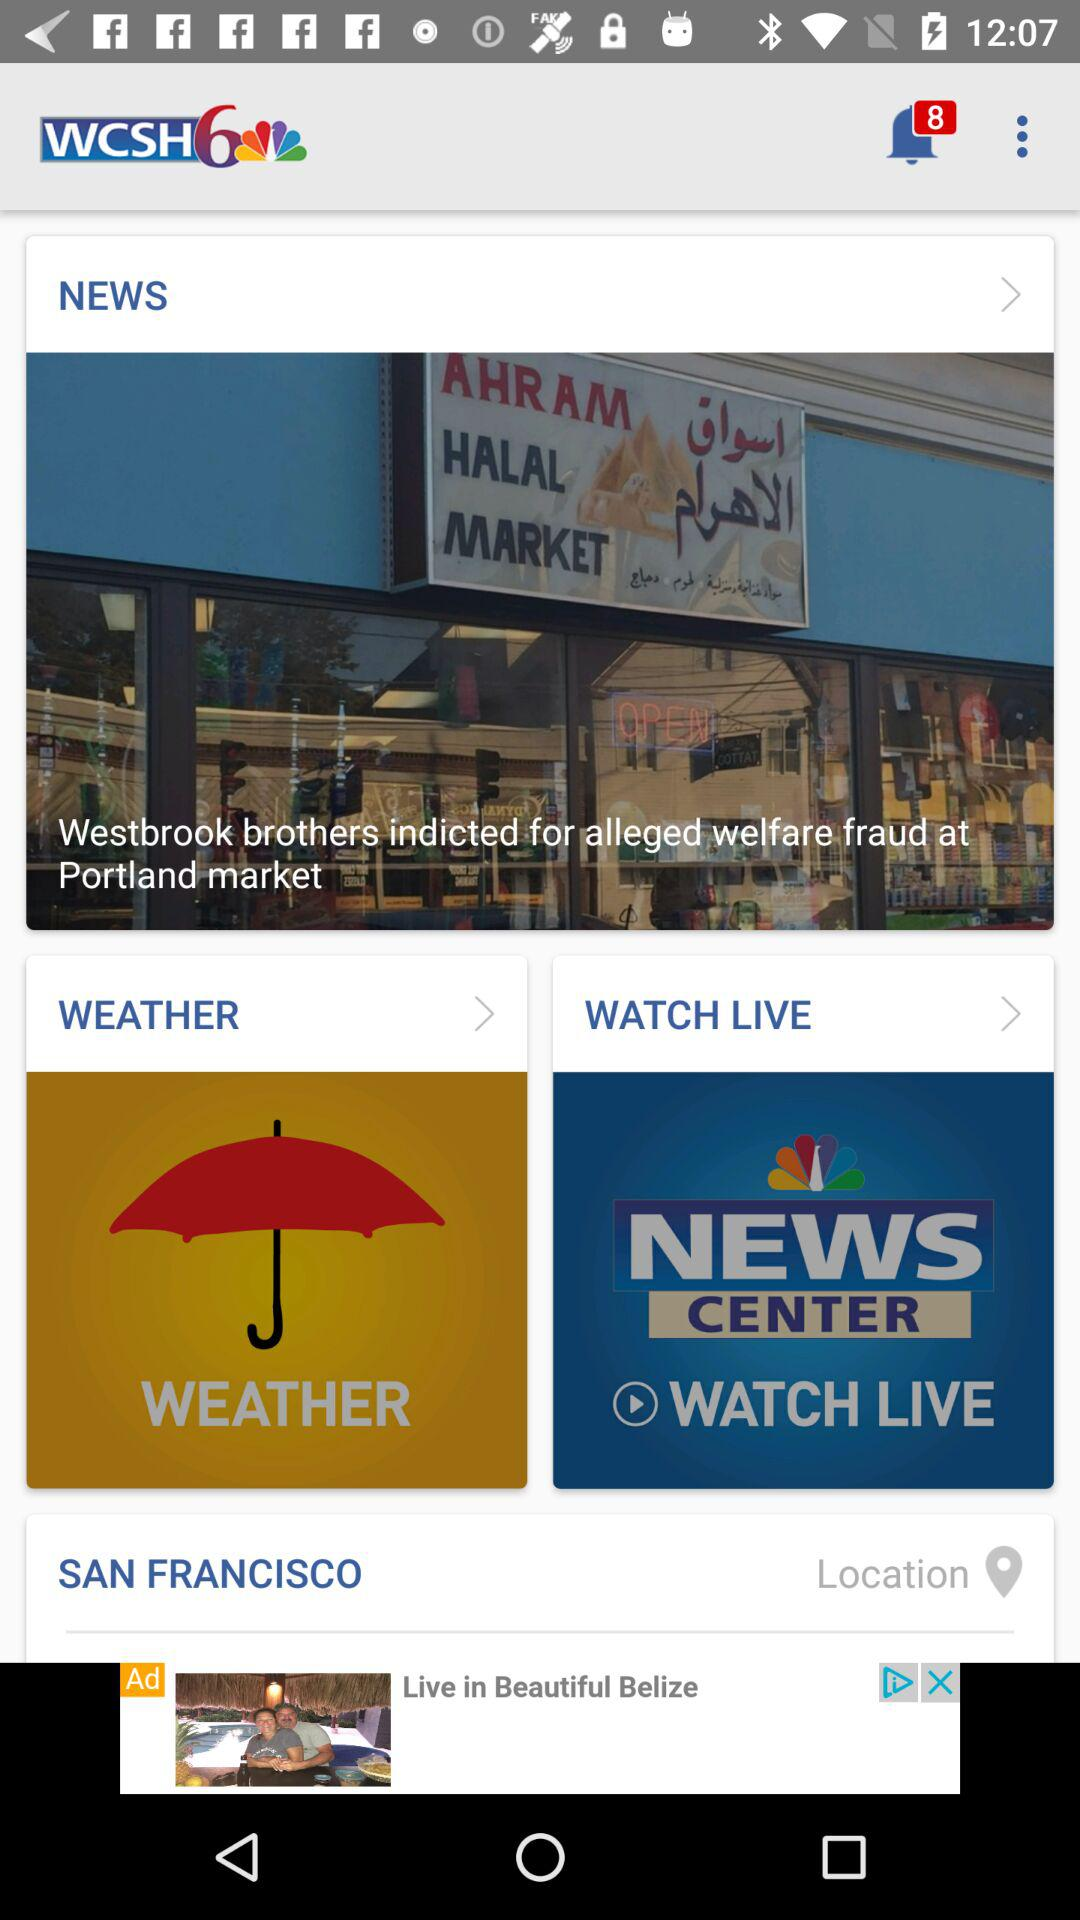What is the name of the news channel? The name of the news channel is "WCSH". 